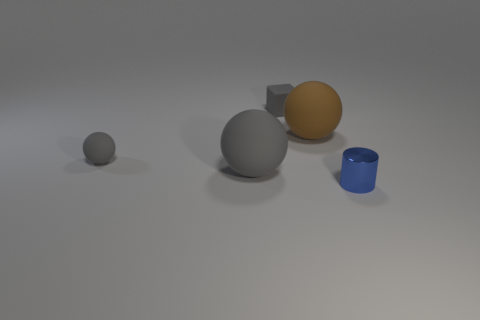The small cube that is made of the same material as the small gray sphere is what color?
Provide a short and direct response. Gray. How many tiny purple things have the same material as the small sphere?
Ensure brevity in your answer.  0. Are there the same number of cylinders in front of the matte cube and big gray objects to the right of the small blue metal thing?
Your response must be concise. No. There is a big brown object; does it have the same shape as the small matte thing that is in front of the brown sphere?
Ensure brevity in your answer.  Yes. What is the material of the big sphere that is the same color as the tiny cube?
Make the answer very short. Rubber. Is there any other thing that is the same shape as the blue shiny object?
Your response must be concise. No. Is the material of the big gray ball the same as the tiny thing right of the tiny gray rubber block?
Ensure brevity in your answer.  No. There is a big rubber ball on the left side of the small thing that is behind the big matte ball behind the small ball; what is its color?
Give a very brief answer. Gray. There is a small matte sphere; does it have the same color as the large matte object on the left side of the block?
Provide a short and direct response. Yes. What is the color of the small cylinder?
Your response must be concise. Blue. 